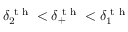<formula> <loc_0><loc_0><loc_500><loc_500>\delta _ { 2 } ^ { t h } < \delta _ { + } ^ { t h } < \delta _ { 1 } ^ { t h }</formula> 